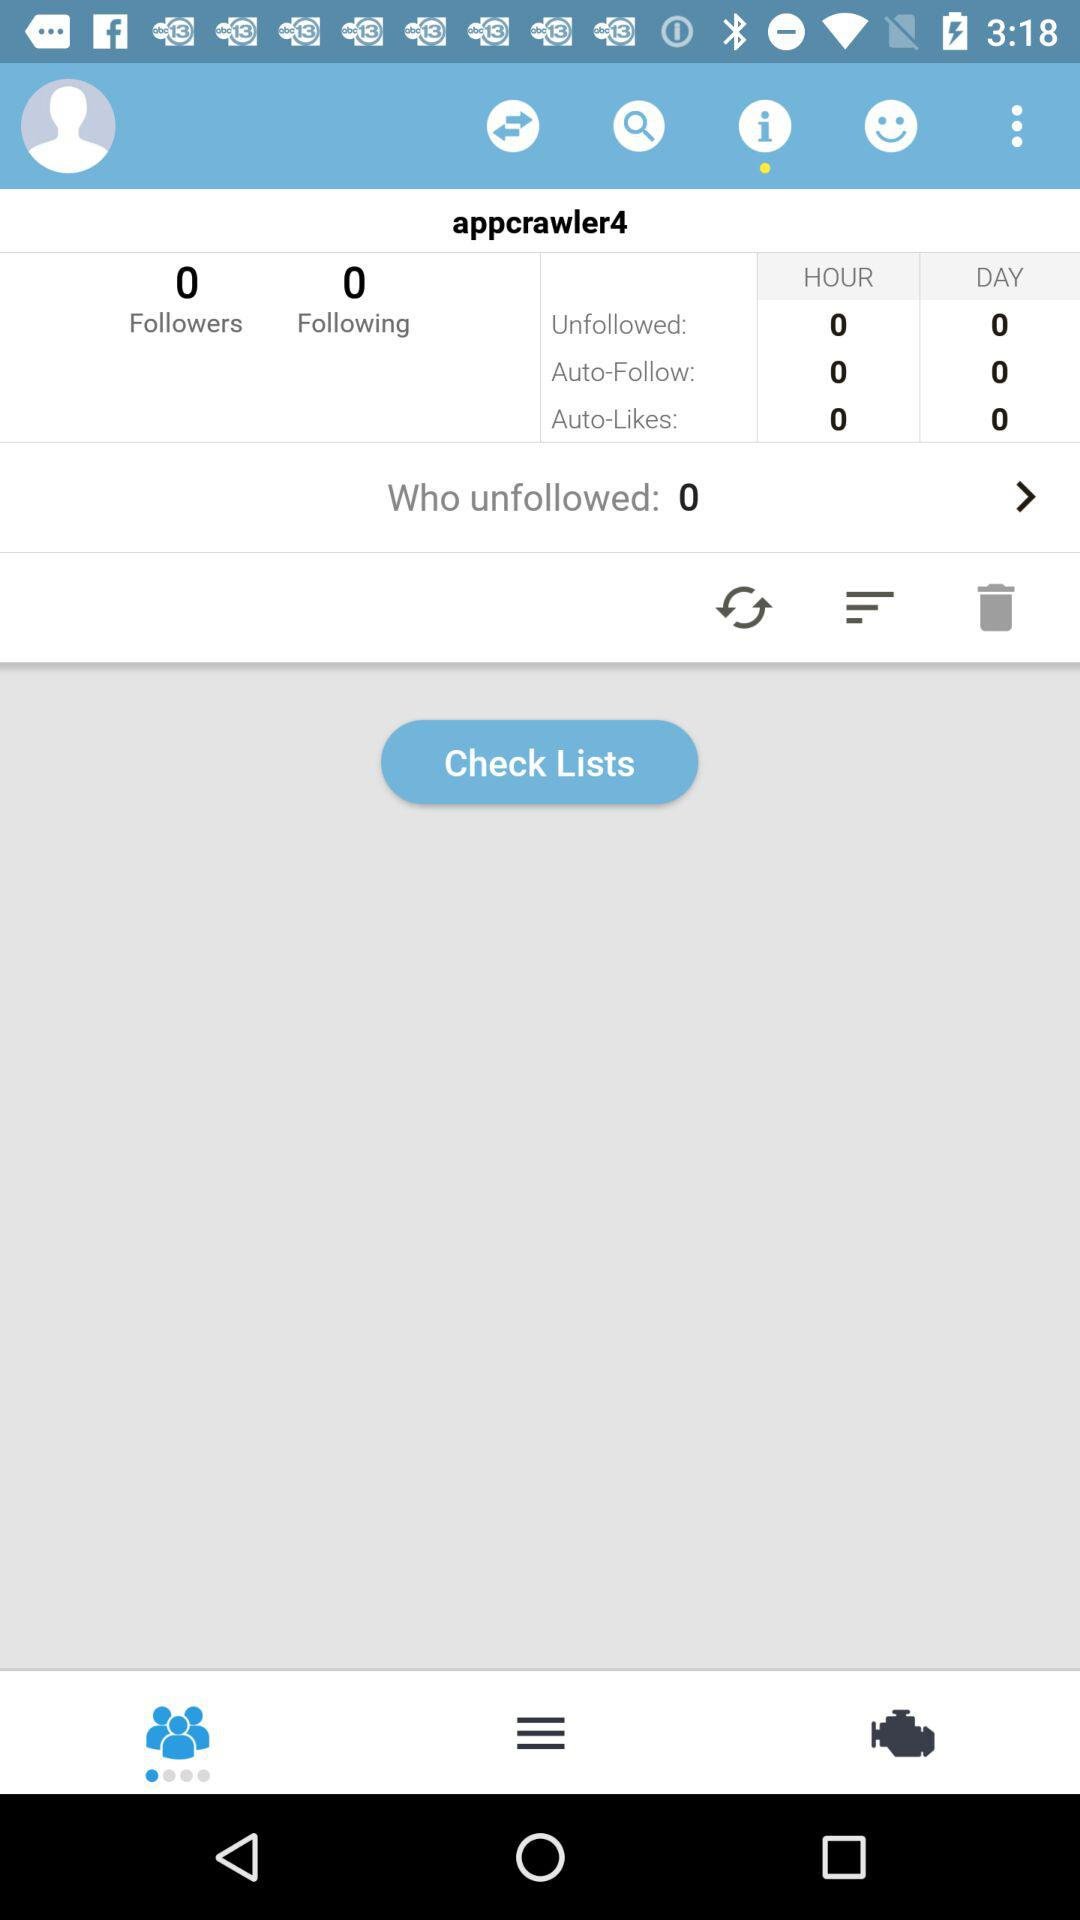What is the count of auto-likes in an hour? The count of auto-likes in an hour is 0. 